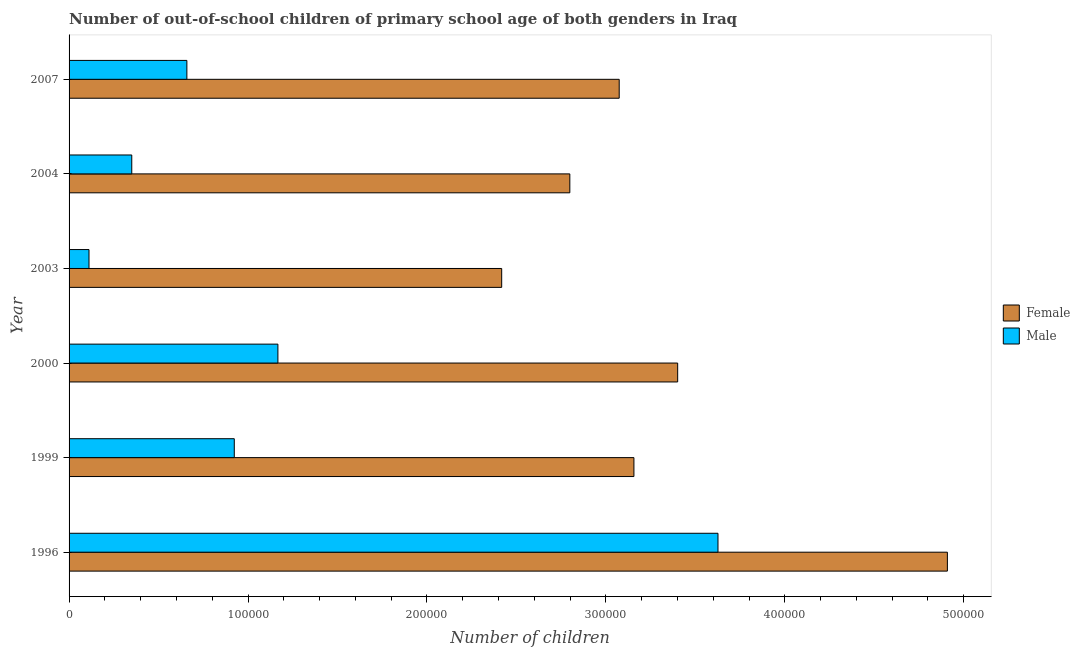How many different coloured bars are there?
Offer a terse response. 2. Are the number of bars on each tick of the Y-axis equal?
Your answer should be very brief. Yes. How many bars are there on the 5th tick from the top?
Ensure brevity in your answer.  2. In how many cases, is the number of bars for a given year not equal to the number of legend labels?
Offer a terse response. 0. What is the number of female out-of-school students in 2003?
Ensure brevity in your answer.  2.42e+05. Across all years, what is the maximum number of male out-of-school students?
Your response must be concise. 3.63e+05. Across all years, what is the minimum number of male out-of-school students?
Your answer should be compact. 1.11e+04. What is the total number of female out-of-school students in the graph?
Offer a very short reply. 1.98e+06. What is the difference between the number of female out-of-school students in 1999 and that in 2003?
Provide a short and direct response. 7.39e+04. What is the difference between the number of female out-of-school students in 2004 and the number of male out-of-school students in 1996?
Offer a terse response. -8.28e+04. What is the average number of female out-of-school students per year?
Your answer should be very brief. 3.29e+05. In the year 1999, what is the difference between the number of female out-of-school students and number of male out-of-school students?
Make the answer very short. 2.23e+05. What is the difference between the highest and the second highest number of female out-of-school students?
Offer a terse response. 1.51e+05. What is the difference between the highest and the lowest number of male out-of-school students?
Make the answer very short. 3.52e+05. Is the sum of the number of male out-of-school students in 2003 and 2004 greater than the maximum number of female out-of-school students across all years?
Your response must be concise. No. What does the 2nd bar from the top in 2003 represents?
Make the answer very short. Female. How many bars are there?
Offer a terse response. 12. Are all the bars in the graph horizontal?
Make the answer very short. Yes. How many legend labels are there?
Provide a succinct answer. 2. What is the title of the graph?
Your answer should be very brief. Number of out-of-school children of primary school age of both genders in Iraq. What is the label or title of the X-axis?
Ensure brevity in your answer.  Number of children. What is the Number of children in Female in 1996?
Give a very brief answer. 4.91e+05. What is the Number of children in Male in 1996?
Give a very brief answer. 3.63e+05. What is the Number of children of Female in 1999?
Make the answer very short. 3.16e+05. What is the Number of children of Male in 1999?
Provide a succinct answer. 9.23e+04. What is the Number of children in Female in 2000?
Make the answer very short. 3.40e+05. What is the Number of children of Male in 2000?
Ensure brevity in your answer.  1.17e+05. What is the Number of children of Female in 2003?
Your response must be concise. 2.42e+05. What is the Number of children of Male in 2003?
Offer a very short reply. 1.11e+04. What is the Number of children in Female in 2004?
Offer a terse response. 2.80e+05. What is the Number of children in Male in 2004?
Ensure brevity in your answer.  3.50e+04. What is the Number of children in Female in 2007?
Provide a succinct answer. 3.07e+05. What is the Number of children of Male in 2007?
Provide a short and direct response. 6.58e+04. Across all years, what is the maximum Number of children of Female?
Keep it short and to the point. 4.91e+05. Across all years, what is the maximum Number of children in Male?
Your answer should be very brief. 3.63e+05. Across all years, what is the minimum Number of children of Female?
Provide a succinct answer. 2.42e+05. Across all years, what is the minimum Number of children in Male?
Your answer should be very brief. 1.11e+04. What is the total Number of children in Female in the graph?
Offer a terse response. 1.98e+06. What is the total Number of children of Male in the graph?
Offer a terse response. 6.84e+05. What is the difference between the Number of children of Female in 1996 and that in 1999?
Keep it short and to the point. 1.75e+05. What is the difference between the Number of children of Male in 1996 and that in 1999?
Your answer should be very brief. 2.70e+05. What is the difference between the Number of children in Female in 1996 and that in 2000?
Make the answer very short. 1.51e+05. What is the difference between the Number of children in Male in 1996 and that in 2000?
Offer a terse response. 2.46e+05. What is the difference between the Number of children in Female in 1996 and that in 2003?
Give a very brief answer. 2.49e+05. What is the difference between the Number of children in Male in 1996 and that in 2003?
Make the answer very short. 3.52e+05. What is the difference between the Number of children in Female in 1996 and that in 2004?
Offer a terse response. 2.11e+05. What is the difference between the Number of children in Male in 1996 and that in 2004?
Your answer should be very brief. 3.28e+05. What is the difference between the Number of children in Female in 1996 and that in 2007?
Your answer should be compact. 1.83e+05. What is the difference between the Number of children in Male in 1996 and that in 2007?
Offer a terse response. 2.97e+05. What is the difference between the Number of children of Female in 1999 and that in 2000?
Make the answer very short. -2.45e+04. What is the difference between the Number of children in Male in 1999 and that in 2000?
Your answer should be compact. -2.44e+04. What is the difference between the Number of children in Female in 1999 and that in 2003?
Your response must be concise. 7.39e+04. What is the difference between the Number of children of Male in 1999 and that in 2003?
Offer a very short reply. 8.12e+04. What is the difference between the Number of children of Female in 1999 and that in 2004?
Make the answer very short. 3.58e+04. What is the difference between the Number of children of Male in 1999 and that in 2004?
Ensure brevity in your answer.  5.73e+04. What is the difference between the Number of children in Female in 1999 and that in 2007?
Offer a terse response. 8220. What is the difference between the Number of children in Male in 1999 and that in 2007?
Offer a terse response. 2.65e+04. What is the difference between the Number of children of Female in 2000 and that in 2003?
Provide a succinct answer. 9.84e+04. What is the difference between the Number of children in Male in 2000 and that in 2003?
Offer a terse response. 1.06e+05. What is the difference between the Number of children in Female in 2000 and that in 2004?
Your answer should be very brief. 6.03e+04. What is the difference between the Number of children of Male in 2000 and that in 2004?
Give a very brief answer. 8.17e+04. What is the difference between the Number of children of Female in 2000 and that in 2007?
Provide a short and direct response. 3.27e+04. What is the difference between the Number of children in Male in 2000 and that in 2007?
Provide a succinct answer. 5.09e+04. What is the difference between the Number of children in Female in 2003 and that in 2004?
Give a very brief answer. -3.81e+04. What is the difference between the Number of children of Male in 2003 and that in 2004?
Your response must be concise. -2.39e+04. What is the difference between the Number of children in Female in 2003 and that in 2007?
Your response must be concise. -6.57e+04. What is the difference between the Number of children of Male in 2003 and that in 2007?
Offer a terse response. -5.47e+04. What is the difference between the Number of children of Female in 2004 and that in 2007?
Provide a succinct answer. -2.76e+04. What is the difference between the Number of children of Male in 2004 and that in 2007?
Keep it short and to the point. -3.08e+04. What is the difference between the Number of children of Female in 1996 and the Number of children of Male in 1999?
Ensure brevity in your answer.  3.99e+05. What is the difference between the Number of children of Female in 1996 and the Number of children of Male in 2000?
Offer a terse response. 3.74e+05. What is the difference between the Number of children of Female in 1996 and the Number of children of Male in 2003?
Ensure brevity in your answer.  4.80e+05. What is the difference between the Number of children of Female in 1996 and the Number of children of Male in 2004?
Offer a very short reply. 4.56e+05. What is the difference between the Number of children of Female in 1996 and the Number of children of Male in 2007?
Make the answer very short. 4.25e+05. What is the difference between the Number of children in Female in 1999 and the Number of children in Male in 2000?
Make the answer very short. 1.99e+05. What is the difference between the Number of children in Female in 1999 and the Number of children in Male in 2003?
Your answer should be very brief. 3.05e+05. What is the difference between the Number of children in Female in 1999 and the Number of children in Male in 2004?
Ensure brevity in your answer.  2.81e+05. What is the difference between the Number of children in Female in 1999 and the Number of children in Male in 2007?
Your response must be concise. 2.50e+05. What is the difference between the Number of children in Female in 2000 and the Number of children in Male in 2003?
Keep it short and to the point. 3.29e+05. What is the difference between the Number of children of Female in 2000 and the Number of children of Male in 2004?
Your answer should be compact. 3.05e+05. What is the difference between the Number of children of Female in 2000 and the Number of children of Male in 2007?
Keep it short and to the point. 2.74e+05. What is the difference between the Number of children in Female in 2003 and the Number of children in Male in 2004?
Make the answer very short. 2.07e+05. What is the difference between the Number of children of Female in 2003 and the Number of children of Male in 2007?
Give a very brief answer. 1.76e+05. What is the difference between the Number of children in Female in 2004 and the Number of children in Male in 2007?
Your response must be concise. 2.14e+05. What is the average Number of children in Female per year?
Offer a very short reply. 3.29e+05. What is the average Number of children of Male per year?
Your answer should be compact. 1.14e+05. In the year 1996, what is the difference between the Number of children of Female and Number of children of Male?
Keep it short and to the point. 1.28e+05. In the year 1999, what is the difference between the Number of children of Female and Number of children of Male?
Offer a terse response. 2.23e+05. In the year 2000, what is the difference between the Number of children of Female and Number of children of Male?
Your answer should be compact. 2.23e+05. In the year 2003, what is the difference between the Number of children of Female and Number of children of Male?
Ensure brevity in your answer.  2.31e+05. In the year 2004, what is the difference between the Number of children of Female and Number of children of Male?
Give a very brief answer. 2.45e+05. In the year 2007, what is the difference between the Number of children of Female and Number of children of Male?
Offer a terse response. 2.42e+05. What is the ratio of the Number of children in Female in 1996 to that in 1999?
Offer a very short reply. 1.55. What is the ratio of the Number of children in Male in 1996 to that in 1999?
Keep it short and to the point. 3.93. What is the ratio of the Number of children in Female in 1996 to that in 2000?
Your answer should be compact. 1.44. What is the ratio of the Number of children of Male in 1996 to that in 2000?
Give a very brief answer. 3.11. What is the ratio of the Number of children of Female in 1996 to that in 2003?
Make the answer very short. 2.03. What is the ratio of the Number of children in Male in 1996 to that in 2003?
Provide a short and direct response. 32.56. What is the ratio of the Number of children in Female in 1996 to that in 2004?
Offer a terse response. 1.75. What is the ratio of the Number of children in Male in 1996 to that in 2004?
Your response must be concise. 10.35. What is the ratio of the Number of children of Female in 1996 to that in 2007?
Keep it short and to the point. 1.6. What is the ratio of the Number of children of Male in 1996 to that in 2007?
Ensure brevity in your answer.  5.51. What is the ratio of the Number of children in Female in 1999 to that in 2000?
Ensure brevity in your answer.  0.93. What is the ratio of the Number of children in Male in 1999 to that in 2000?
Your response must be concise. 0.79. What is the ratio of the Number of children of Female in 1999 to that in 2003?
Your response must be concise. 1.31. What is the ratio of the Number of children in Male in 1999 to that in 2003?
Your answer should be very brief. 8.29. What is the ratio of the Number of children of Female in 1999 to that in 2004?
Your answer should be very brief. 1.13. What is the ratio of the Number of children in Male in 1999 to that in 2004?
Your response must be concise. 2.64. What is the ratio of the Number of children in Female in 1999 to that in 2007?
Offer a very short reply. 1.03. What is the ratio of the Number of children in Male in 1999 to that in 2007?
Provide a short and direct response. 1.4. What is the ratio of the Number of children in Female in 2000 to that in 2003?
Provide a short and direct response. 1.41. What is the ratio of the Number of children of Male in 2000 to that in 2003?
Give a very brief answer. 10.48. What is the ratio of the Number of children in Female in 2000 to that in 2004?
Ensure brevity in your answer.  1.22. What is the ratio of the Number of children of Male in 2000 to that in 2004?
Your answer should be compact. 3.33. What is the ratio of the Number of children in Female in 2000 to that in 2007?
Your answer should be very brief. 1.11. What is the ratio of the Number of children in Male in 2000 to that in 2007?
Offer a terse response. 1.77. What is the ratio of the Number of children of Female in 2003 to that in 2004?
Give a very brief answer. 0.86. What is the ratio of the Number of children of Male in 2003 to that in 2004?
Ensure brevity in your answer.  0.32. What is the ratio of the Number of children of Female in 2003 to that in 2007?
Ensure brevity in your answer.  0.79. What is the ratio of the Number of children in Male in 2003 to that in 2007?
Make the answer very short. 0.17. What is the ratio of the Number of children in Female in 2004 to that in 2007?
Make the answer very short. 0.91. What is the ratio of the Number of children in Male in 2004 to that in 2007?
Ensure brevity in your answer.  0.53. What is the difference between the highest and the second highest Number of children in Female?
Provide a succinct answer. 1.51e+05. What is the difference between the highest and the second highest Number of children in Male?
Your response must be concise. 2.46e+05. What is the difference between the highest and the lowest Number of children of Female?
Offer a terse response. 2.49e+05. What is the difference between the highest and the lowest Number of children of Male?
Ensure brevity in your answer.  3.52e+05. 